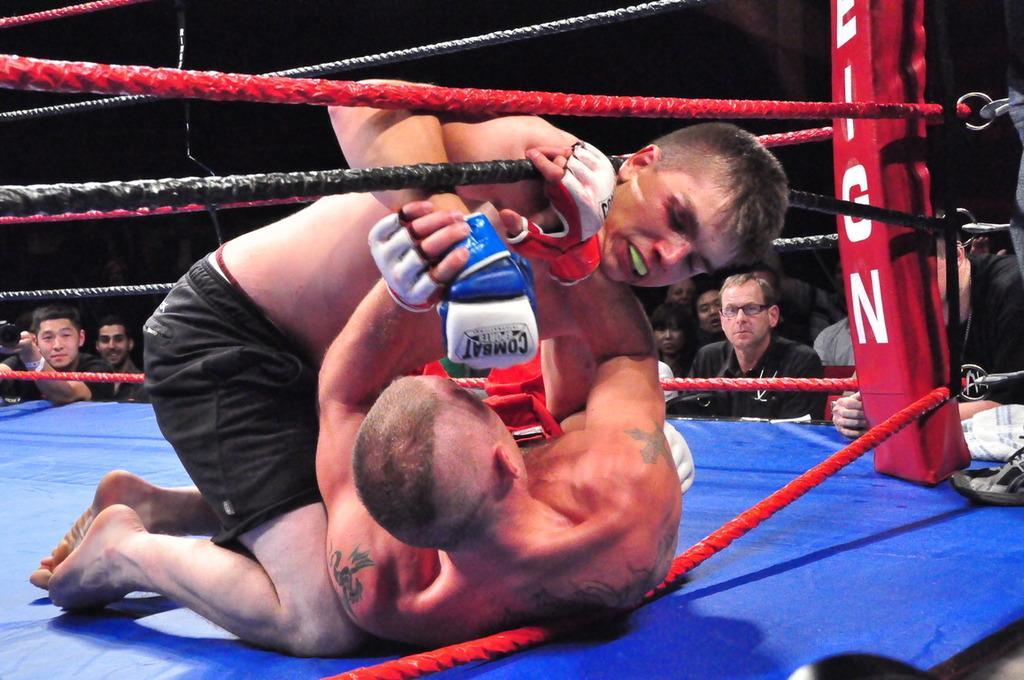Please provide a concise description of this image. In this image, we can see two men are fighting on the blue surface. Here we can see ropes. In the background we can see a group of people are watching. Here we can see a dark view. 